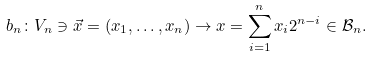<formula> <loc_0><loc_0><loc_500><loc_500>b _ { n } \colon V _ { n } \ni \vec { x } = ( x _ { 1 } , \dots , x _ { n } ) \to x = \sum ^ { n } _ { i = 1 } x _ { i } 2 ^ { n - i } \in \mathcal { B } _ { n } .</formula> 